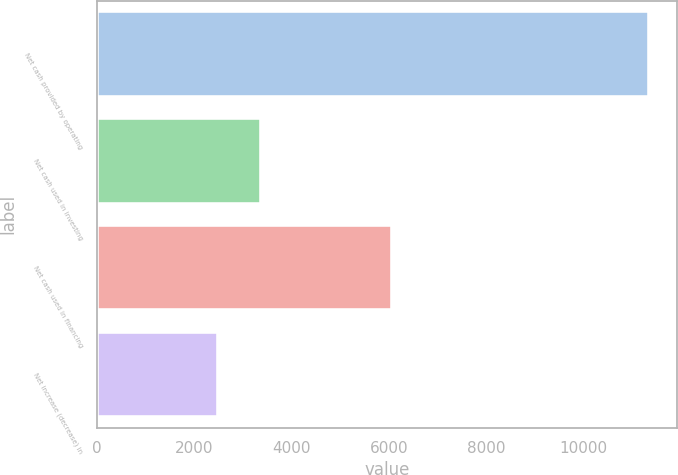Convert chart. <chart><loc_0><loc_0><loc_500><loc_500><bar_chart><fcel>Net cash provided by operating<fcel>Net cash used in investing<fcel>Net cash used in financing<fcel>Net increase (decrease) in<nl><fcel>11353<fcel>3375.4<fcel>6077<fcel>2489<nl></chart> 